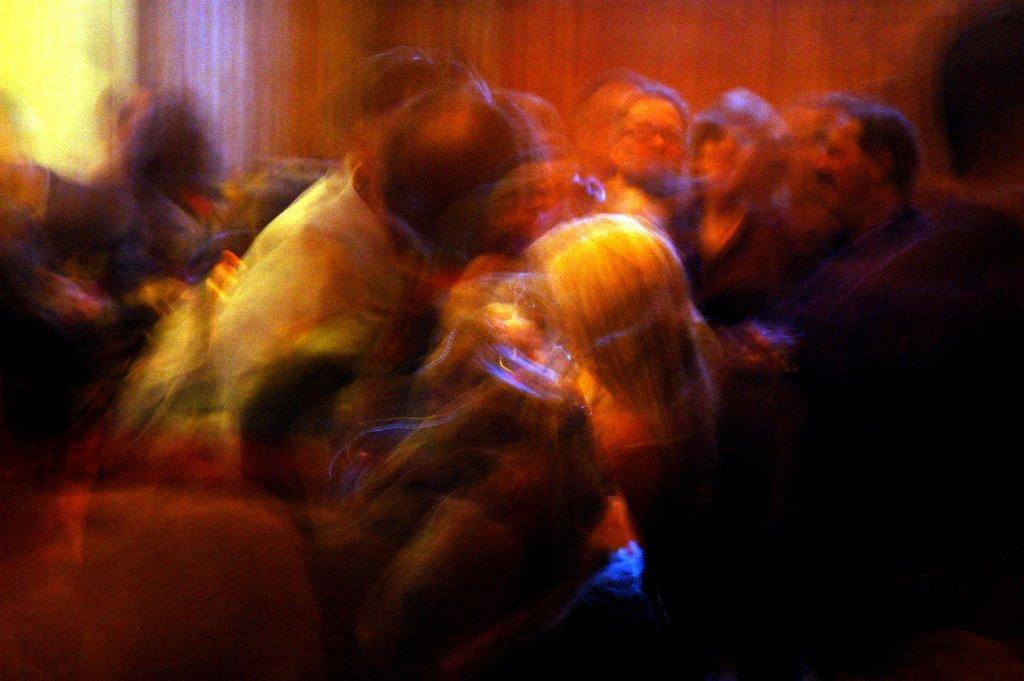Could you give a brief overview of what you see in this image? It is a blurred image there are a lot of people in a room, their images are not clear. 